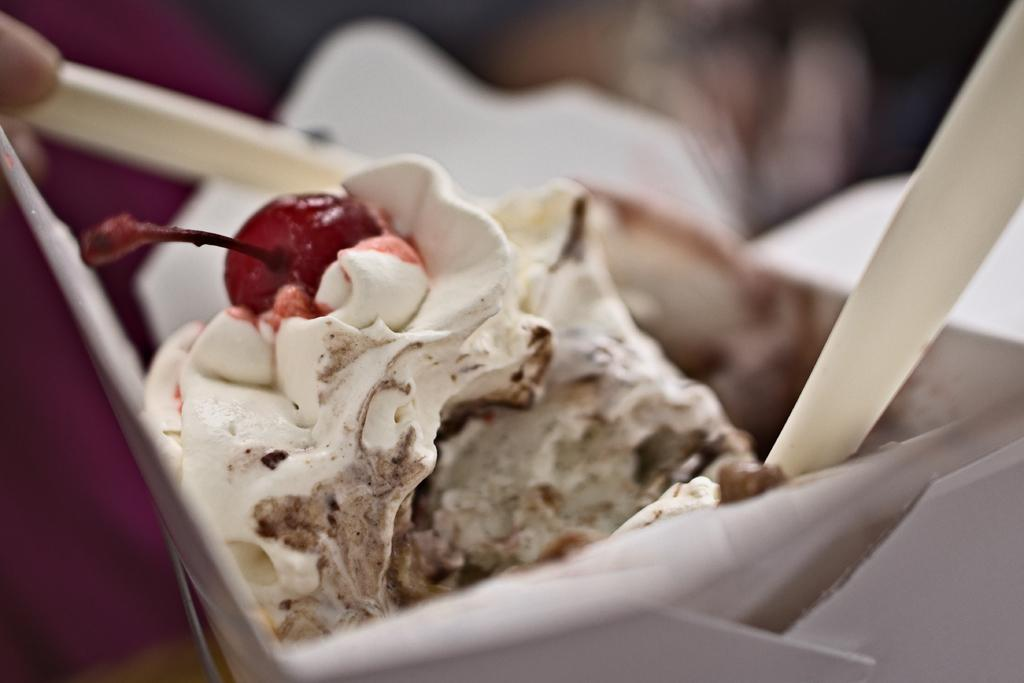What is the main subject of the image? The main subject of the image is an ice-cream. What is placed on top of the ice-cream? There is a red cherry on top of the ice-cream. What color is the bowl containing the ice-cream and cherry? The bowl is white in color. What utensils are visible in the image? Spoons are visible in the image. Can you describe the background of the image? The background of the image is blurred. What type of car can be seen driving through the volcano in the image? There is no car or volcano present in the image; it features an ice-cream with a cherry on top in a white bowl. What happens to the ice-cream when it gets smashed in the image? There is no indication in the image that the ice-cream gets smashed, as it appears to be intact in the bowl. 